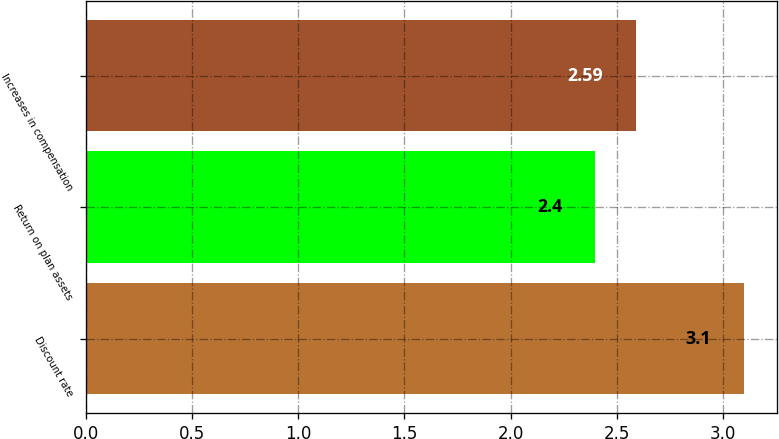Convert chart. <chart><loc_0><loc_0><loc_500><loc_500><bar_chart><fcel>Discount rate<fcel>Return on plan assets<fcel>Increases in compensation<nl><fcel>3.1<fcel>2.4<fcel>2.59<nl></chart> 